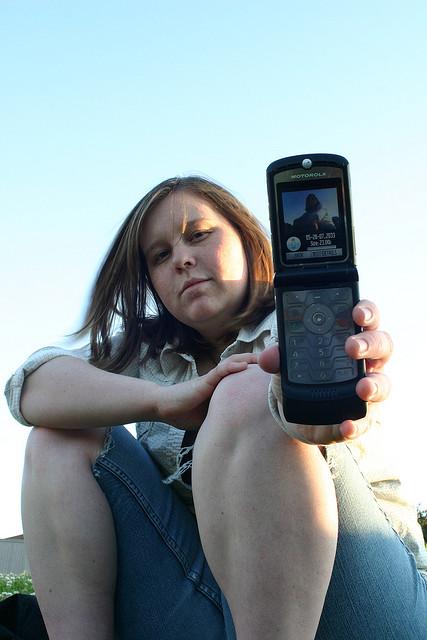What brand of phone is she holding?
Be succinct. Motorola. Are there any clouds in the sky?
Short answer required. No. On which side of her head is her hair parted?
Quick response, please. Left. 